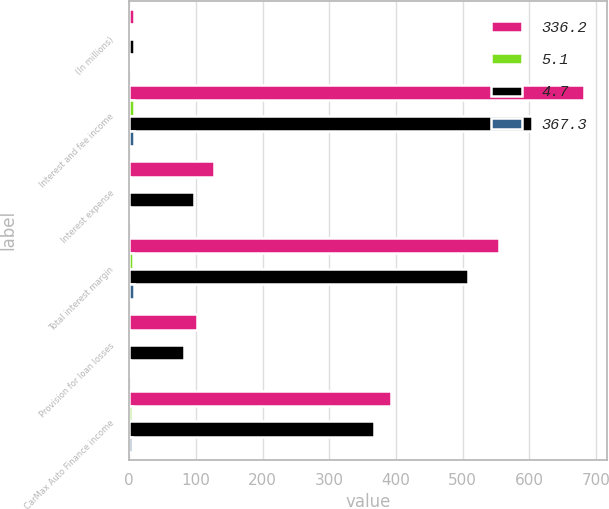Convert chart. <chart><loc_0><loc_0><loc_500><loc_500><stacked_bar_chart><ecel><fcel>(In millions)<fcel>Interest and fee income<fcel>Interest expense<fcel>Total interest margin<fcel>Provision for loan losses<fcel>CarMax Auto Finance income<nl><fcel>336.2<fcel>7.6<fcel>682.9<fcel>127.7<fcel>555.2<fcel>101.2<fcel>392<nl><fcel>5.1<fcel>1<fcel>7.5<fcel>1.4<fcel>6.1<fcel>1.1<fcel>4.3<nl><fcel>4.7<fcel>7.6<fcel>604.9<fcel>96.6<fcel>508.3<fcel>82.3<fcel>367.3<nl><fcel>367.3<fcel>1<fcel>7.7<fcel>1.2<fcel>6.5<fcel>1<fcel>4.7<nl></chart> 